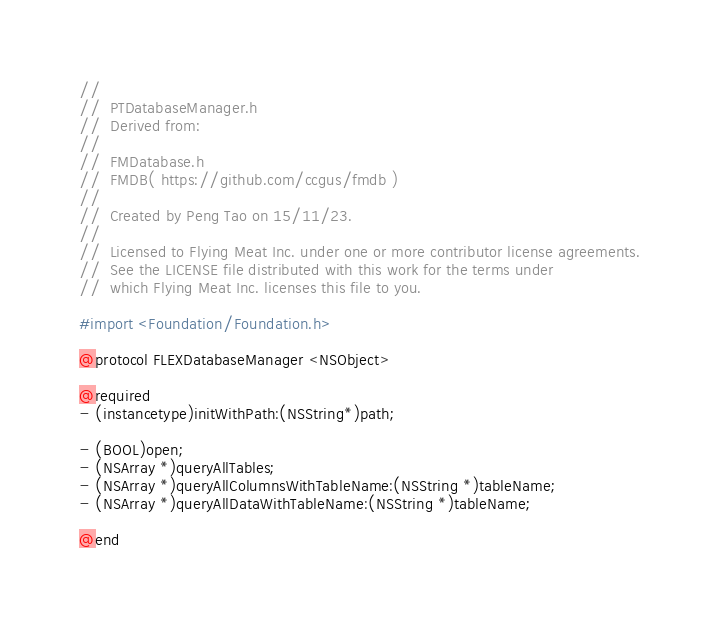<code> <loc_0><loc_0><loc_500><loc_500><_C_>//
//  PTDatabaseManager.h
//  Derived from:
//
//  FMDatabase.h
//  FMDB( https://github.com/ccgus/fmdb )
//
//  Created by Peng Tao on 15/11/23.
//
//  Licensed to Flying Meat Inc. under one or more contributor license agreements.
//  See the LICENSE file distributed with this work for the terms under
//  which Flying Meat Inc. licenses this file to you.

#import <Foundation/Foundation.h>

@protocol FLEXDatabaseManager <NSObject>

@required
- (instancetype)initWithPath:(NSString*)path;

- (BOOL)open;
- (NSArray *)queryAllTables;
- (NSArray *)queryAllColumnsWithTableName:(NSString *)tableName;
- (NSArray *)queryAllDataWithTableName:(NSString *)tableName;

@end
</code> 